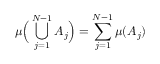<formula> <loc_0><loc_0><loc_500><loc_500>\mu { \left ( } \bigcup _ { j = 1 } ^ { N - 1 } A _ { j } { \right ) } = \sum _ { j = 1 } ^ { N - 1 } \mu ( A _ { j } )</formula> 